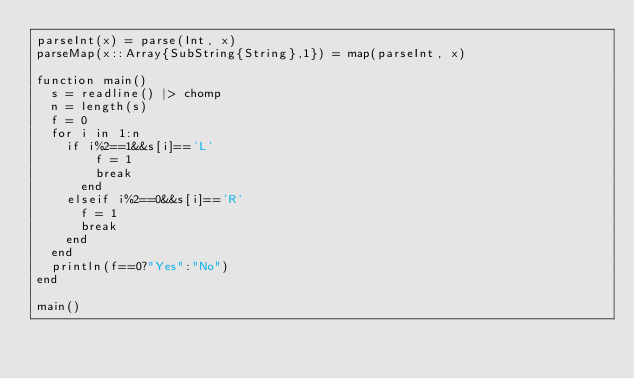Convert code to text. <code><loc_0><loc_0><loc_500><loc_500><_Julia_>parseInt(x) = parse(Int, x)
parseMap(x::Array{SubString{String},1}) = map(parseInt, x)

function main()
	s = readline() |> chomp
	n = length(s)
	f = 0
	for i in 1:n
		if i%2==1&&s[i]=='L'
				f = 1
				break
			end
		elseif i%2==0&&s[i]=='R'
			f = 1
			break
		end
	end
	println(f==0?"Yes":"No")
end

main()</code> 